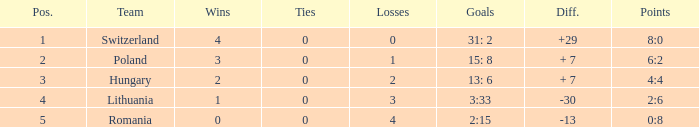What is the highest number of victories when the total losses were fewer than 4 and there were over 0 draws? None. Can you give me this table as a dict? {'header': ['Pos.', 'Team', 'Wins', 'Ties', 'Losses', 'Goals', 'Diff.', 'Points'], 'rows': [['1', 'Switzerland', '4', '0', '0', '31: 2', '+29', '8:0'], ['2', 'Poland', '3', '0', '1', '15: 8', '+ 7', '6:2'], ['3', 'Hungary', '2', '0', '2', '13: 6', '+ 7', '4:4'], ['4', 'Lithuania', '1', '0', '3', '3:33', '-30', '2:6'], ['5', 'Romania', '0', '0', '4', '2:15', '-13', '0:8']]} 